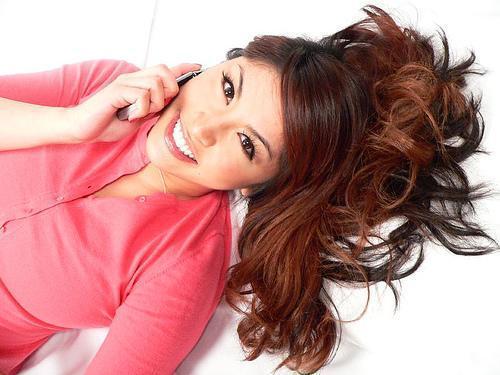How many phones does she have?
Give a very brief answer. 1. How many bike on this image?
Give a very brief answer. 0. 